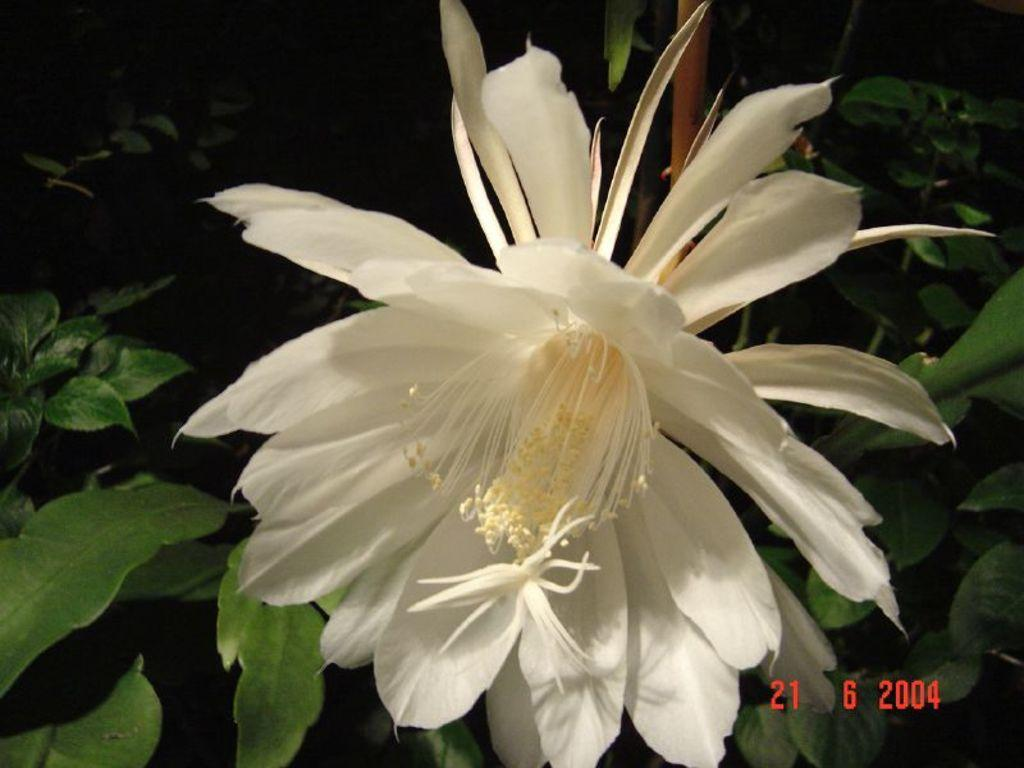What is the main subject of the image? There is a flower in the image. What can be seen in the background of the image? There are leaves in the background of the image. Where are the numbers located in the image? The numbers are in the right bottom corner of the image. How many fingers can be seen holding the flower in the image? There are no fingers or hands holding the flower in the image; it is a standalone flower. 